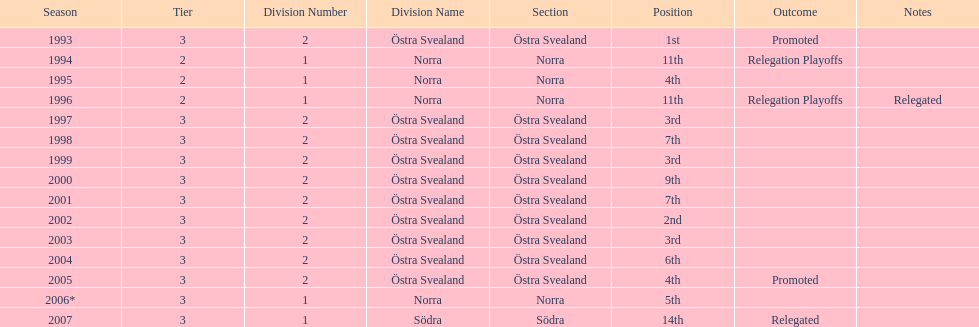What is listed under the movements column of the last season? Relegated. 